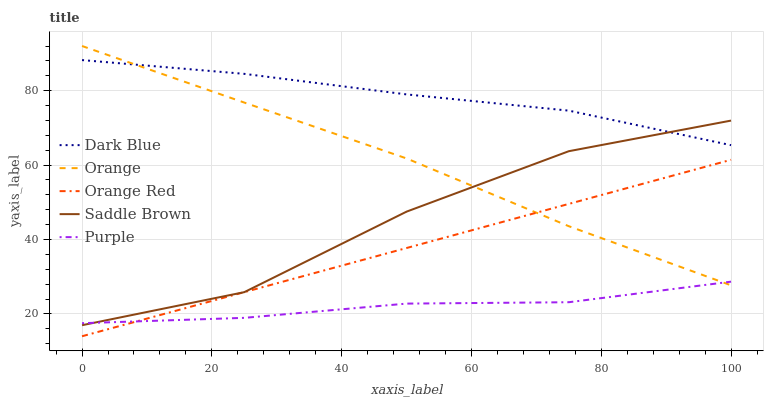Does Purple have the minimum area under the curve?
Answer yes or no. Yes. Does Dark Blue have the maximum area under the curve?
Answer yes or no. Yes. Does Orange Red have the minimum area under the curve?
Answer yes or no. No. Does Orange Red have the maximum area under the curve?
Answer yes or no. No. Is Orange Red the smoothest?
Answer yes or no. Yes. Is Saddle Brown the roughest?
Answer yes or no. Yes. Is Dark Blue the smoothest?
Answer yes or no. No. Is Dark Blue the roughest?
Answer yes or no. No. Does Orange Red have the lowest value?
Answer yes or no. Yes. Does Dark Blue have the lowest value?
Answer yes or no. No. Does Orange have the highest value?
Answer yes or no. Yes. Does Dark Blue have the highest value?
Answer yes or no. No. Is Orange Red less than Dark Blue?
Answer yes or no. Yes. Is Dark Blue greater than Purple?
Answer yes or no. Yes. Does Saddle Brown intersect Orange?
Answer yes or no. Yes. Is Saddle Brown less than Orange?
Answer yes or no. No. Is Saddle Brown greater than Orange?
Answer yes or no. No. Does Orange Red intersect Dark Blue?
Answer yes or no. No. 